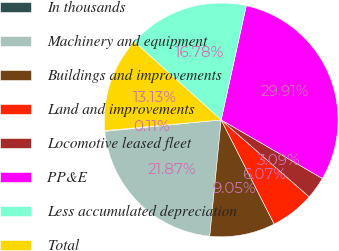<chart> <loc_0><loc_0><loc_500><loc_500><pie_chart><fcel>In thousands<fcel>Machinery and equipment<fcel>Buildings and improvements<fcel>Land and improvements<fcel>Locomotive leased fleet<fcel>PP&E<fcel>Less accumulated depreciation<fcel>Total<nl><fcel>0.11%<fcel>21.87%<fcel>9.05%<fcel>6.07%<fcel>3.09%<fcel>29.91%<fcel>16.78%<fcel>13.13%<nl></chart> 